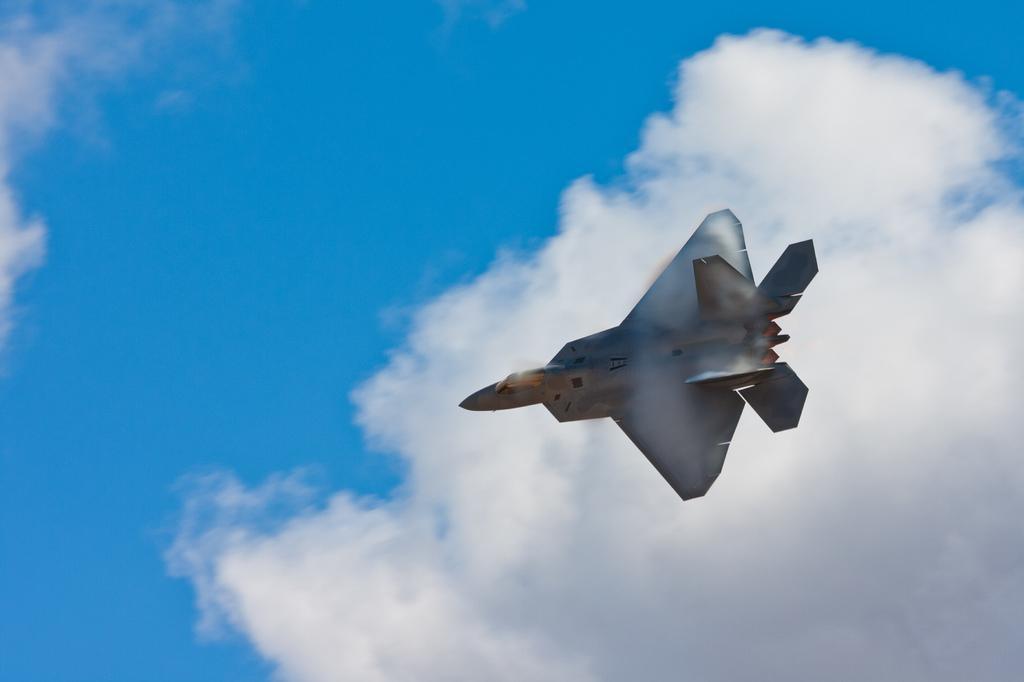In one or two sentences, can you explain what this image depicts? In this image there is an aircraft flying in the sky. At the top there are clouds. 